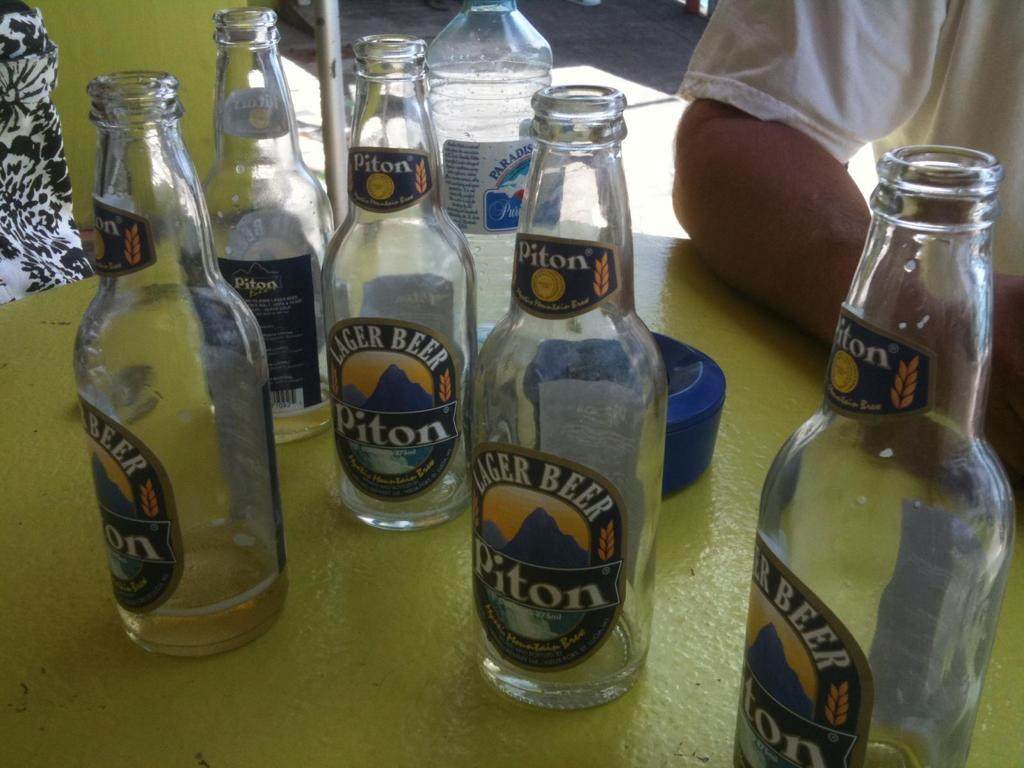<image>
Give a short and clear explanation of the subsequent image. Piton lager beer bottles sit empty on a table. 